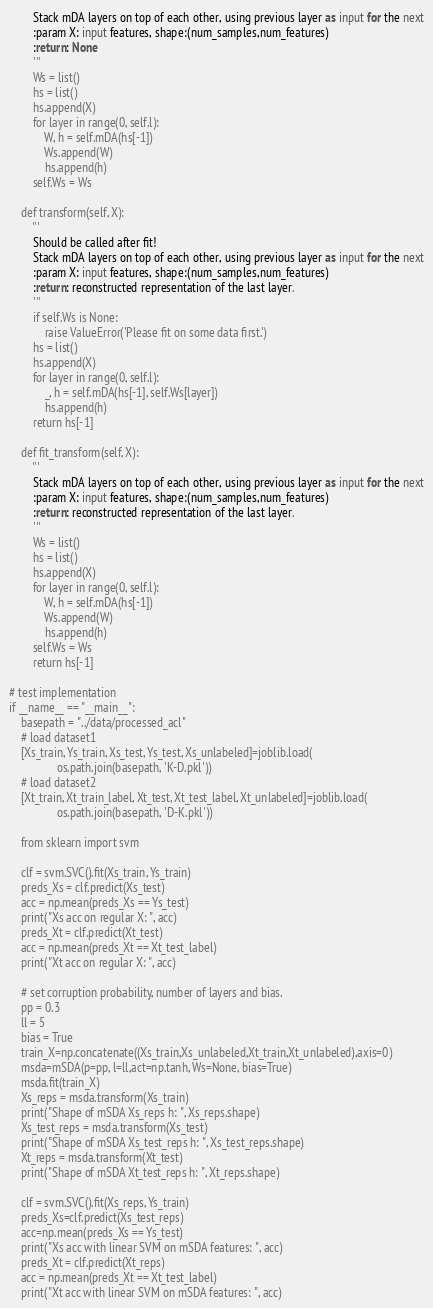Convert code to text. <code><loc_0><loc_0><loc_500><loc_500><_Python_>        Stack mDA layers on top of each other, using previous layer as input for the next
        :param X: input features, shape:(num_samples,num_features)
        :return: None
        '''
        Ws = list()
        hs = list()
        hs.append(X)
        for layer in range(0, self.l):
            W, h = self.mDA(hs[-1])
            Ws.append(W)
            hs.append(h)
        self.Ws = Ws

    def transform(self, X):
        '''
        Should be called after fit!
        Stack mDA layers on top of each other, using previous layer as input for the next
        :param X: input features, shape:(num_samples,num_features)
        :return: reconstructed representation of the last layer.
        '''
        if self.Ws is None:
            raise ValueError('Please fit on some data first.')
        hs = list()
        hs.append(X)
        for layer in range(0, self.l):
            _, h = self.mDA(hs[-1], self.Ws[layer])
            hs.append(h)
        return hs[-1]

    def fit_transform(self, X):
        '''
        Stack mDA layers on top of each other, using previous layer as input for the next
        :param X: input features, shape:(num_samples,num_features)
        :return: reconstructed representation of the last layer.
        '''
        Ws = list()
        hs = list()
        hs.append(X)
        for layer in range(0, self.l):
            W, h = self.mDA(hs[-1])
            Ws.append(W)
            hs.append(h)
        self.Ws = Ws
        return hs[-1]

# test implementation
if __name__ == "__main__":
    basepath = "../data/processed_acl"
    # load dataset1
    [Xs_train, Ys_train, Xs_test, Ys_test, Xs_unlabeled]=joblib.load(
                os.path.join(basepath, 'K-D.pkl'))
    # load dataset2
    [Xt_train, Xt_train_label, Xt_test, Xt_test_label, Xt_unlabeled]=joblib.load(
                os.path.join(basepath, 'D-K.pkl'))

    from sklearn import svm

    clf = svm.SVC().fit(Xs_train, Ys_train)
    preds_Xs = clf.predict(Xs_test)
    acc = np.mean(preds_Xs == Ys_test)
    print("Xs acc on regular X: ", acc)
    preds_Xt = clf.predict(Xt_test)
    acc = np.mean(preds_Xt == Xt_test_label)
    print("Xt acc on regular X: ", acc)

    # set corruption probability, number of layers and bias.
    pp = 0.3
    ll = 5
    bias = True
    train_X=np.concatenate((Xs_train,Xs_unlabeled,Xt_train,Xt_unlabeled),axis=0)
    msda=mSDA(p=pp, l=ll,act=np.tanh, Ws=None, bias=True)
    msda.fit(train_X)
    Xs_reps = msda.transform(Xs_train)
    print("Shape of mSDA Xs_reps h: ", Xs_reps.shape)
    Xs_test_reps = msda.transform(Xs_test)
    print("Shape of mSDA Xs_test_reps h: ", Xs_test_reps.shape)
    Xt_reps = msda.transform(Xt_test)
    print("Shape of mSDA Xt_test_reps h: ", Xt_reps.shape)

    clf = svm.SVC().fit(Xs_reps, Ys_train)
    preds_Xs=clf.predict(Xs_test_reps)
    acc=np.mean(preds_Xs == Ys_test)
    print("Xs acc with linear SVM on mSDA features: ", acc)
    preds_Xt = clf.predict(Xt_reps)
    acc = np.mean(preds_Xt == Xt_test_label)
    print("Xt acc with linear SVM on mSDA features: ", acc)
</code> 